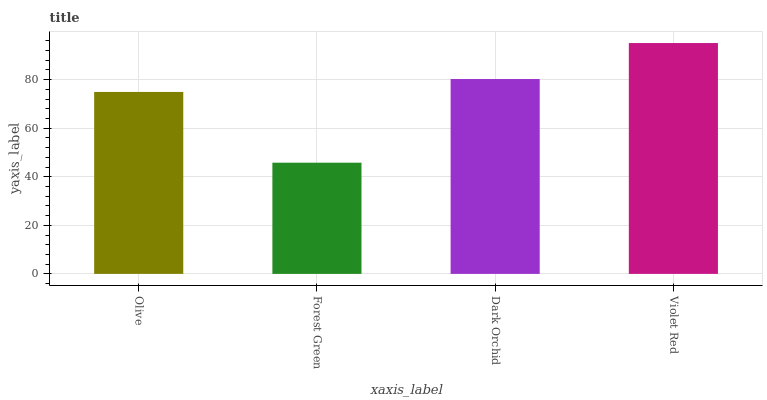Is Forest Green the minimum?
Answer yes or no. Yes. Is Violet Red the maximum?
Answer yes or no. Yes. Is Dark Orchid the minimum?
Answer yes or no. No. Is Dark Orchid the maximum?
Answer yes or no. No. Is Dark Orchid greater than Forest Green?
Answer yes or no. Yes. Is Forest Green less than Dark Orchid?
Answer yes or no. Yes. Is Forest Green greater than Dark Orchid?
Answer yes or no. No. Is Dark Orchid less than Forest Green?
Answer yes or no. No. Is Dark Orchid the high median?
Answer yes or no. Yes. Is Olive the low median?
Answer yes or no. Yes. Is Violet Red the high median?
Answer yes or no. No. Is Forest Green the low median?
Answer yes or no. No. 